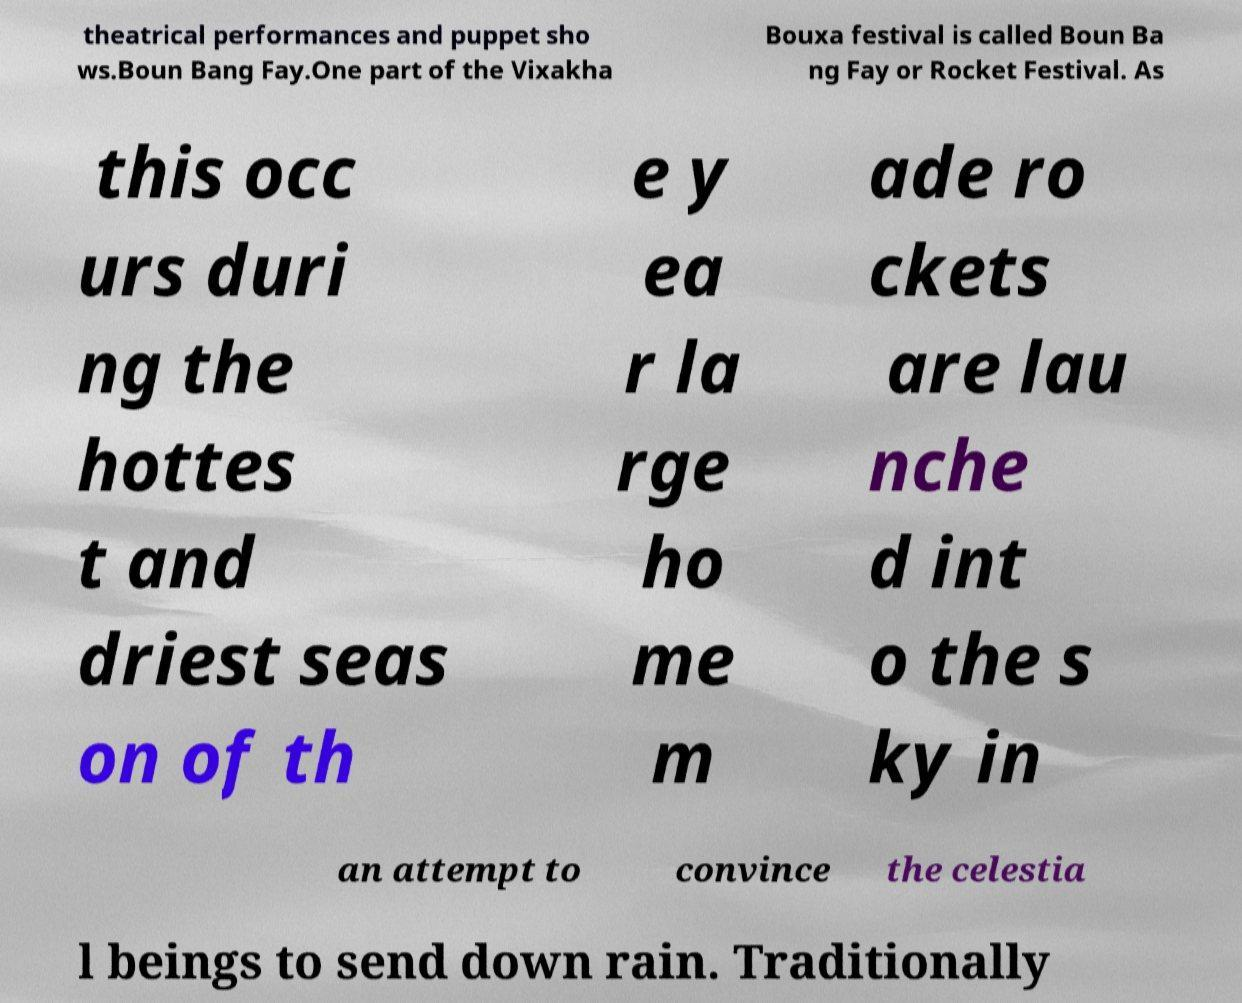For documentation purposes, I need the text within this image transcribed. Could you provide that? theatrical performances and puppet sho ws.Boun Bang Fay.One part of the Vixakha Bouxa festival is called Boun Ba ng Fay or Rocket Festival. As this occ urs duri ng the hottes t and driest seas on of th e y ea r la rge ho me m ade ro ckets are lau nche d int o the s ky in an attempt to convince the celestia l beings to send down rain. Traditionally 